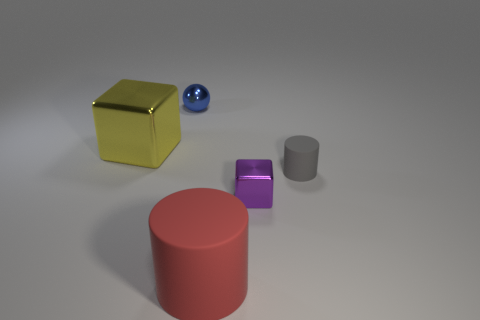What materials do the objects in the image appear to be made from? The objects in the image seem to be made from various materials: the yellow object has a metallic sheen suggesting it is made of metal, the blue object looks like shiny ceramic or glass due to its reflective surface, the pink and purple objects have a matte finish that could imply a plastic or painted wood composition, and the gray object has a dull metal finish. 